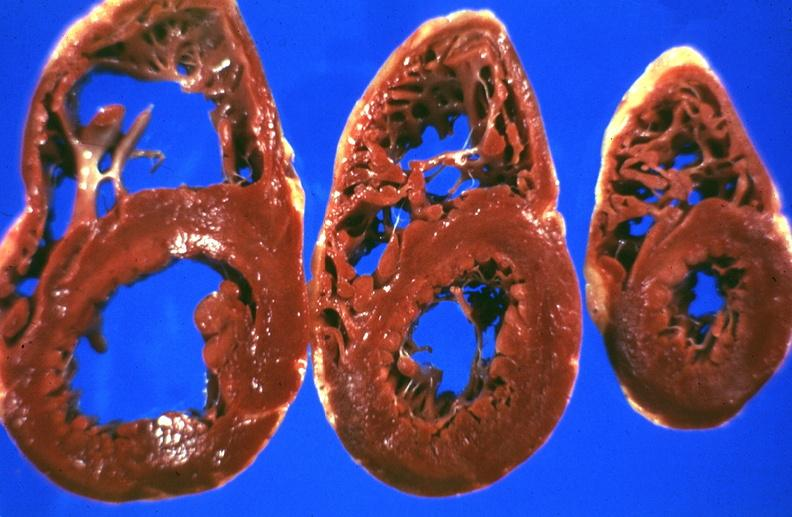what does this image show?
Answer the question using a single word or phrase. Liver 